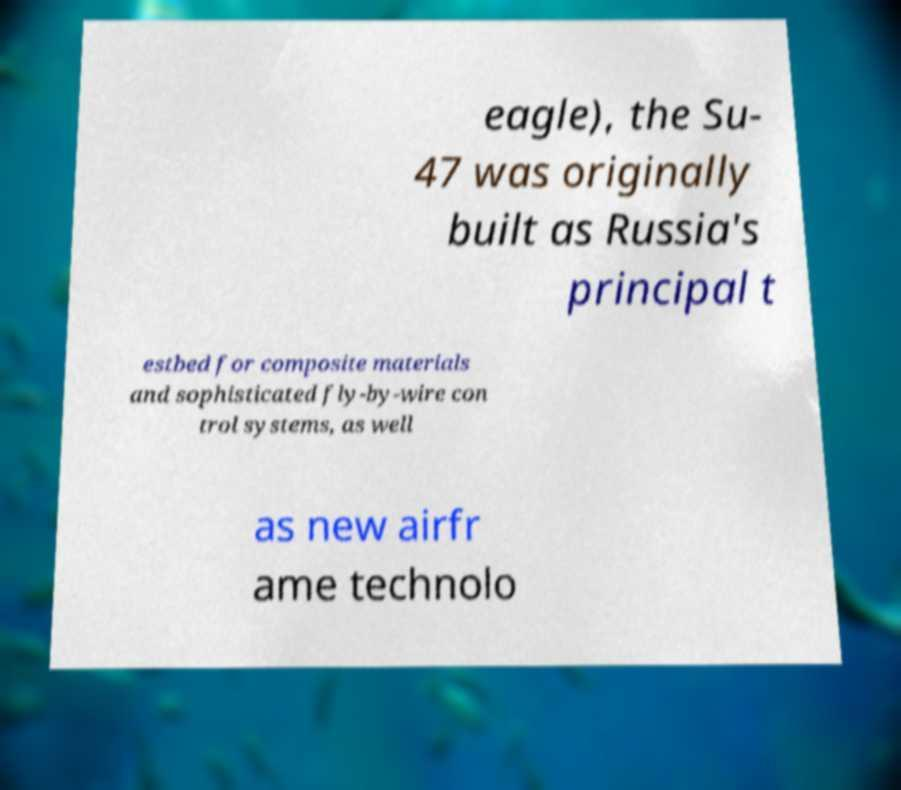Can you accurately transcribe the text from the provided image for me? eagle), the Su- 47 was originally built as Russia's principal t estbed for composite materials and sophisticated fly-by-wire con trol systems, as well as new airfr ame technolo 